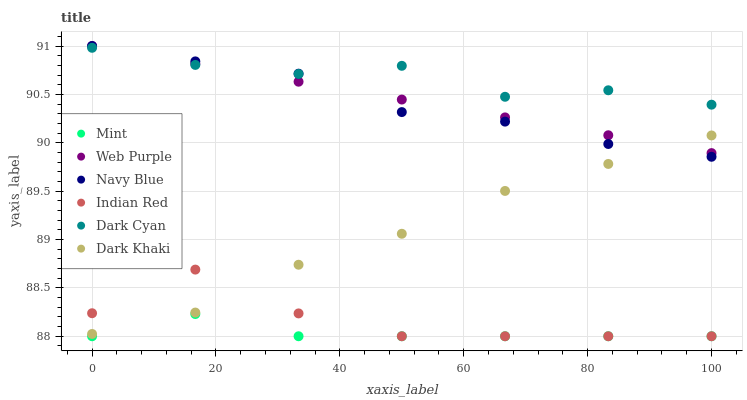Does Mint have the minimum area under the curve?
Answer yes or no. Yes. Does Dark Cyan have the maximum area under the curve?
Answer yes or no. Yes. Does Dark Khaki have the minimum area under the curve?
Answer yes or no. No. Does Dark Khaki have the maximum area under the curve?
Answer yes or no. No. Is Web Purple the smoothest?
Answer yes or no. Yes. Is Indian Red the roughest?
Answer yes or no. Yes. Is Dark Khaki the smoothest?
Answer yes or no. No. Is Dark Khaki the roughest?
Answer yes or no. No. Does Indian Red have the lowest value?
Answer yes or no. Yes. Does Dark Khaki have the lowest value?
Answer yes or no. No. Does Web Purple have the highest value?
Answer yes or no. Yes. Does Dark Khaki have the highest value?
Answer yes or no. No. Is Mint less than Navy Blue?
Answer yes or no. Yes. Is Web Purple greater than Mint?
Answer yes or no. Yes. Does Indian Red intersect Mint?
Answer yes or no. Yes. Is Indian Red less than Mint?
Answer yes or no. No. Is Indian Red greater than Mint?
Answer yes or no. No. Does Mint intersect Navy Blue?
Answer yes or no. No. 